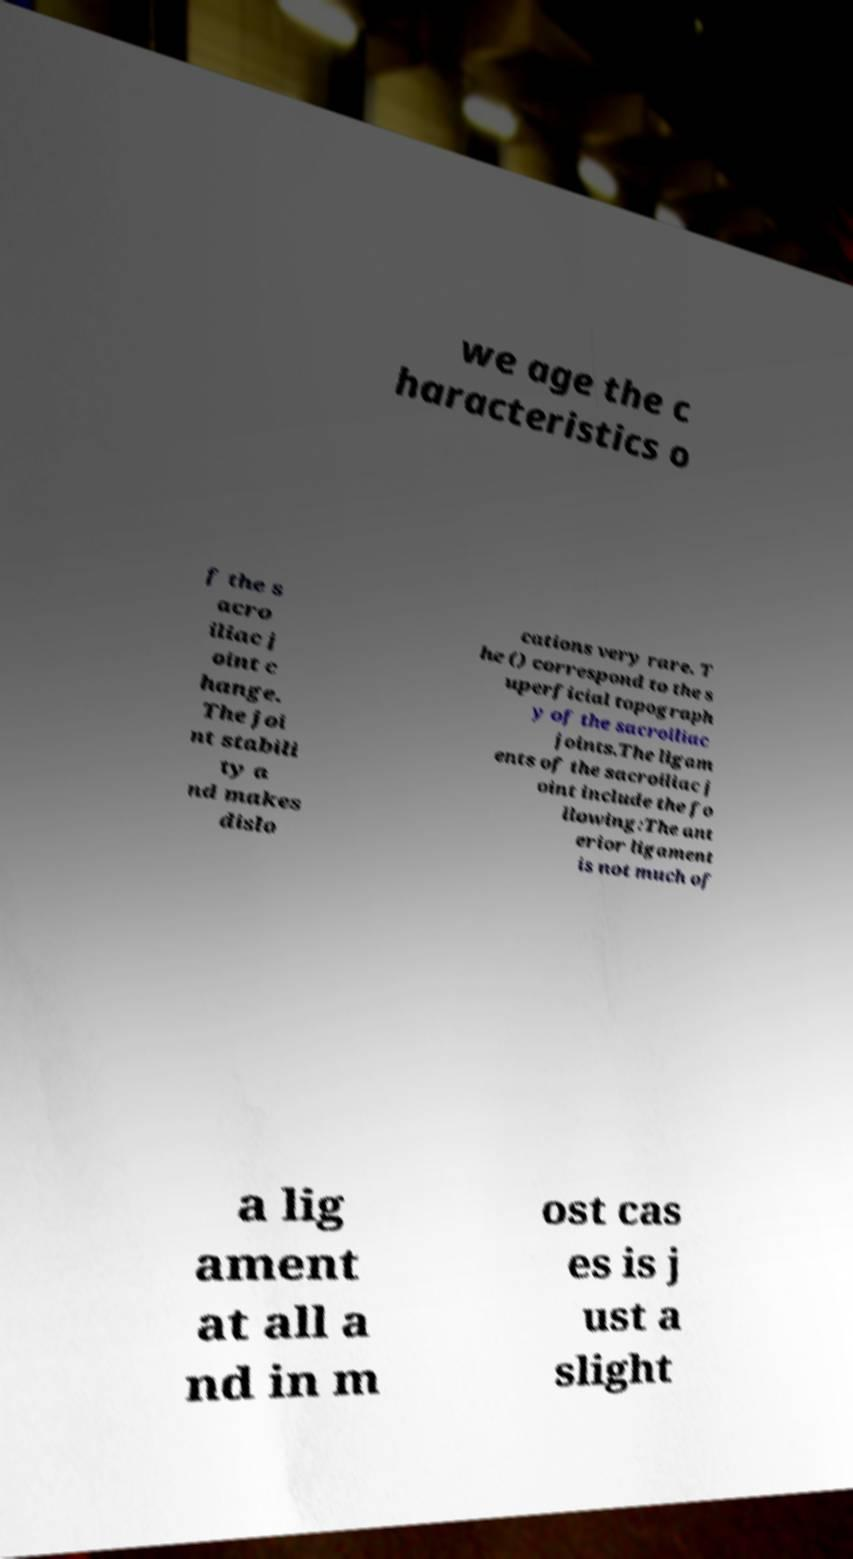Please identify and transcribe the text found in this image. we age the c haracteristics o f the s acro iliac j oint c hange. The joi nt stabili ty a nd makes dislo cations very rare. T he () correspond to the s uperficial topograph y of the sacroiliac joints.The ligam ents of the sacroiliac j oint include the fo llowing:The ant erior ligament is not much of a lig ament at all a nd in m ost cas es is j ust a slight 